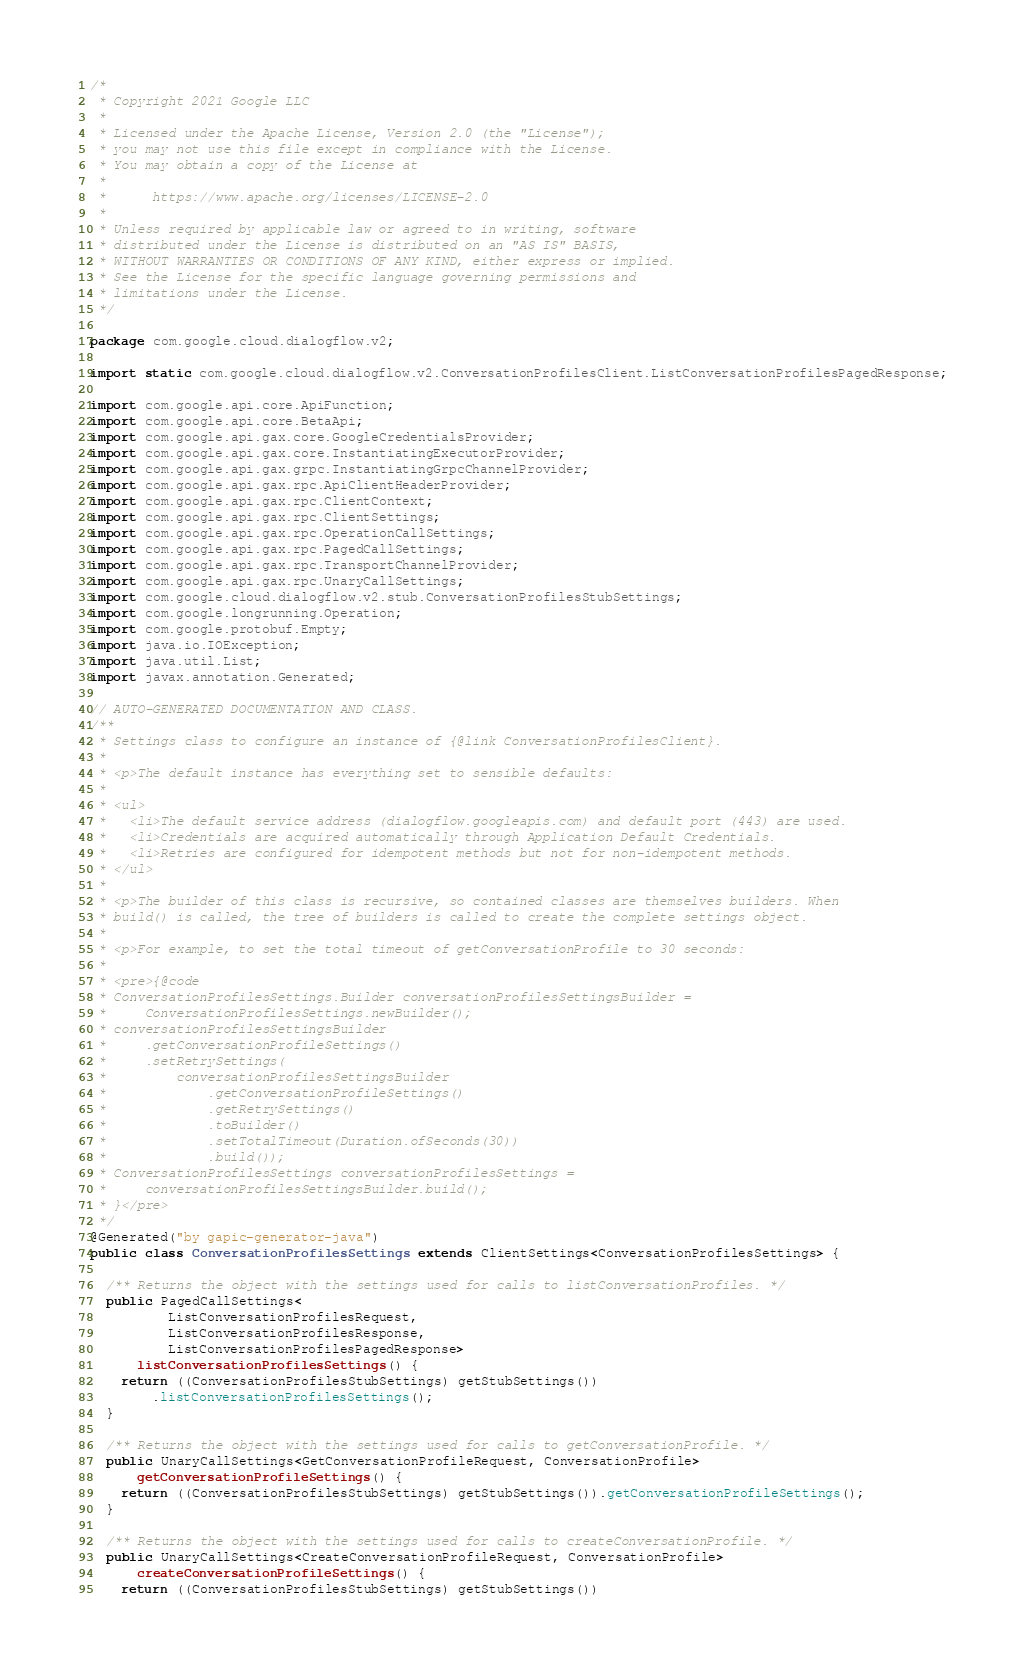<code> <loc_0><loc_0><loc_500><loc_500><_Java_>/*
 * Copyright 2021 Google LLC
 *
 * Licensed under the Apache License, Version 2.0 (the "License");
 * you may not use this file except in compliance with the License.
 * You may obtain a copy of the License at
 *
 *      https://www.apache.org/licenses/LICENSE-2.0
 *
 * Unless required by applicable law or agreed to in writing, software
 * distributed under the License is distributed on an "AS IS" BASIS,
 * WITHOUT WARRANTIES OR CONDITIONS OF ANY KIND, either express or implied.
 * See the License for the specific language governing permissions and
 * limitations under the License.
 */

package com.google.cloud.dialogflow.v2;

import static com.google.cloud.dialogflow.v2.ConversationProfilesClient.ListConversationProfilesPagedResponse;

import com.google.api.core.ApiFunction;
import com.google.api.core.BetaApi;
import com.google.api.gax.core.GoogleCredentialsProvider;
import com.google.api.gax.core.InstantiatingExecutorProvider;
import com.google.api.gax.grpc.InstantiatingGrpcChannelProvider;
import com.google.api.gax.rpc.ApiClientHeaderProvider;
import com.google.api.gax.rpc.ClientContext;
import com.google.api.gax.rpc.ClientSettings;
import com.google.api.gax.rpc.OperationCallSettings;
import com.google.api.gax.rpc.PagedCallSettings;
import com.google.api.gax.rpc.TransportChannelProvider;
import com.google.api.gax.rpc.UnaryCallSettings;
import com.google.cloud.dialogflow.v2.stub.ConversationProfilesStubSettings;
import com.google.longrunning.Operation;
import com.google.protobuf.Empty;
import java.io.IOException;
import java.util.List;
import javax.annotation.Generated;

// AUTO-GENERATED DOCUMENTATION AND CLASS.
/**
 * Settings class to configure an instance of {@link ConversationProfilesClient}.
 *
 * <p>The default instance has everything set to sensible defaults:
 *
 * <ul>
 *   <li>The default service address (dialogflow.googleapis.com) and default port (443) are used.
 *   <li>Credentials are acquired automatically through Application Default Credentials.
 *   <li>Retries are configured for idempotent methods but not for non-idempotent methods.
 * </ul>
 *
 * <p>The builder of this class is recursive, so contained classes are themselves builders. When
 * build() is called, the tree of builders is called to create the complete settings object.
 *
 * <p>For example, to set the total timeout of getConversationProfile to 30 seconds:
 *
 * <pre>{@code
 * ConversationProfilesSettings.Builder conversationProfilesSettingsBuilder =
 *     ConversationProfilesSettings.newBuilder();
 * conversationProfilesSettingsBuilder
 *     .getConversationProfileSettings()
 *     .setRetrySettings(
 *         conversationProfilesSettingsBuilder
 *             .getConversationProfileSettings()
 *             .getRetrySettings()
 *             .toBuilder()
 *             .setTotalTimeout(Duration.ofSeconds(30))
 *             .build());
 * ConversationProfilesSettings conversationProfilesSettings =
 *     conversationProfilesSettingsBuilder.build();
 * }</pre>
 */
@Generated("by gapic-generator-java")
public class ConversationProfilesSettings extends ClientSettings<ConversationProfilesSettings> {

  /** Returns the object with the settings used for calls to listConversationProfiles. */
  public PagedCallSettings<
          ListConversationProfilesRequest,
          ListConversationProfilesResponse,
          ListConversationProfilesPagedResponse>
      listConversationProfilesSettings() {
    return ((ConversationProfilesStubSettings) getStubSettings())
        .listConversationProfilesSettings();
  }

  /** Returns the object with the settings used for calls to getConversationProfile. */
  public UnaryCallSettings<GetConversationProfileRequest, ConversationProfile>
      getConversationProfileSettings() {
    return ((ConversationProfilesStubSettings) getStubSettings()).getConversationProfileSettings();
  }

  /** Returns the object with the settings used for calls to createConversationProfile. */
  public UnaryCallSettings<CreateConversationProfileRequest, ConversationProfile>
      createConversationProfileSettings() {
    return ((ConversationProfilesStubSettings) getStubSettings())</code> 